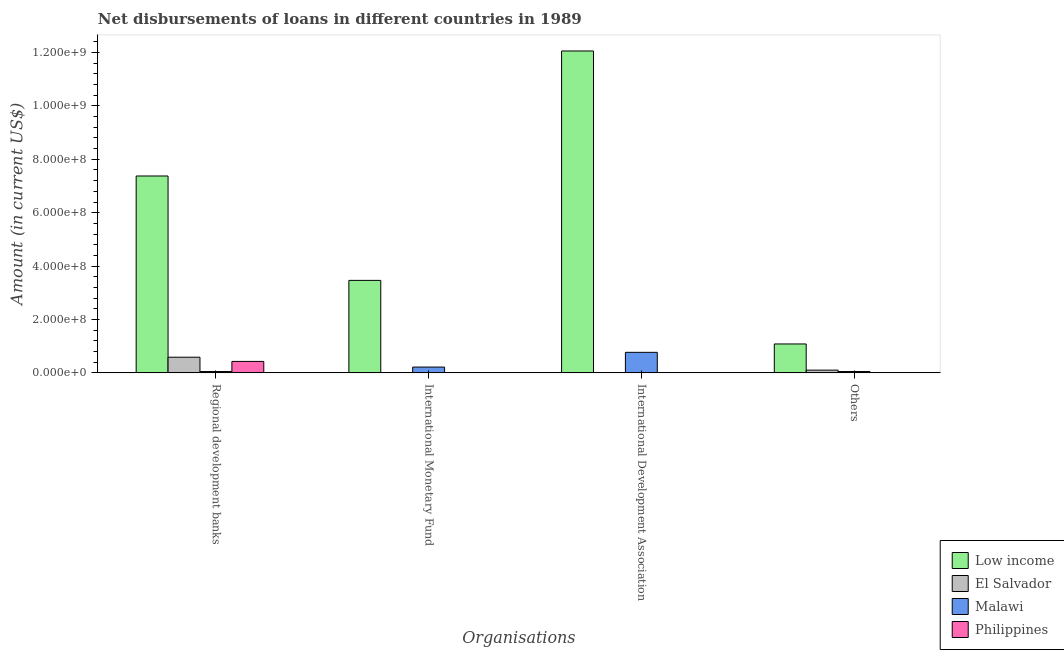How many different coloured bars are there?
Offer a terse response. 4. How many groups of bars are there?
Your response must be concise. 4. Are the number of bars on each tick of the X-axis equal?
Your response must be concise. No. What is the label of the 3rd group of bars from the left?
Offer a very short reply. International Development Association. What is the amount of loan disimbursed by international development association in Philippines?
Offer a very short reply. 6.10e+05. Across all countries, what is the maximum amount of loan disimbursed by other organisations?
Offer a terse response. 1.08e+08. What is the total amount of loan disimbursed by other organisations in the graph?
Make the answer very short. 1.24e+08. What is the difference between the amount of loan disimbursed by regional development banks in Malawi and that in Low income?
Give a very brief answer. -7.33e+08. What is the difference between the amount of loan disimbursed by international development association in Philippines and the amount of loan disimbursed by regional development banks in El Salvador?
Offer a terse response. -5.80e+07. What is the average amount of loan disimbursed by other organisations per country?
Offer a terse response. 3.09e+07. What is the difference between the amount of loan disimbursed by international monetary fund and amount of loan disimbursed by international development association in Malawi?
Ensure brevity in your answer.  -5.52e+07. In how many countries, is the amount of loan disimbursed by regional development banks greater than 680000000 US$?
Offer a very short reply. 1. What is the ratio of the amount of loan disimbursed by international development association in Malawi to that in Philippines?
Offer a terse response. 126.05. Is the difference between the amount of loan disimbursed by other organisations in Low income and Malawi greater than the difference between the amount of loan disimbursed by international development association in Low income and Malawi?
Give a very brief answer. No. What is the difference between the highest and the second highest amount of loan disimbursed by international development association?
Make the answer very short. 1.13e+09. What is the difference between the highest and the lowest amount of loan disimbursed by international monetary fund?
Provide a short and direct response. 3.46e+08. In how many countries, is the amount of loan disimbursed by international monetary fund greater than the average amount of loan disimbursed by international monetary fund taken over all countries?
Give a very brief answer. 1. Is the sum of the amount of loan disimbursed by other organisations in Malawi and El Salvador greater than the maximum amount of loan disimbursed by international development association across all countries?
Keep it short and to the point. No. Are all the bars in the graph horizontal?
Your answer should be compact. No. Does the graph contain any zero values?
Keep it short and to the point. Yes. Does the graph contain grids?
Provide a short and direct response. No. How are the legend labels stacked?
Your response must be concise. Vertical. What is the title of the graph?
Your response must be concise. Net disbursements of loans in different countries in 1989. What is the label or title of the X-axis?
Ensure brevity in your answer.  Organisations. What is the Amount (in current US$) of Low income in Regional development banks?
Ensure brevity in your answer.  7.38e+08. What is the Amount (in current US$) of El Salvador in Regional development banks?
Make the answer very short. 5.87e+07. What is the Amount (in current US$) in Malawi in Regional development banks?
Provide a succinct answer. 4.95e+06. What is the Amount (in current US$) of Philippines in Regional development banks?
Offer a very short reply. 4.29e+07. What is the Amount (in current US$) in Low income in International Monetary Fund?
Keep it short and to the point. 3.46e+08. What is the Amount (in current US$) of Malawi in International Monetary Fund?
Your response must be concise. 2.17e+07. What is the Amount (in current US$) of Philippines in International Monetary Fund?
Ensure brevity in your answer.  0. What is the Amount (in current US$) in Low income in International Development Association?
Ensure brevity in your answer.  1.21e+09. What is the Amount (in current US$) of El Salvador in International Development Association?
Provide a short and direct response. 0. What is the Amount (in current US$) in Malawi in International Development Association?
Keep it short and to the point. 7.69e+07. What is the Amount (in current US$) of Philippines in International Development Association?
Keep it short and to the point. 6.10e+05. What is the Amount (in current US$) of Low income in Others?
Offer a very short reply. 1.08e+08. What is the Amount (in current US$) in El Salvador in Others?
Provide a succinct answer. 1.02e+07. What is the Amount (in current US$) of Malawi in Others?
Offer a very short reply. 4.99e+06. Across all Organisations, what is the maximum Amount (in current US$) of Low income?
Your answer should be compact. 1.21e+09. Across all Organisations, what is the maximum Amount (in current US$) in El Salvador?
Offer a terse response. 5.87e+07. Across all Organisations, what is the maximum Amount (in current US$) of Malawi?
Provide a short and direct response. 7.69e+07. Across all Organisations, what is the maximum Amount (in current US$) in Philippines?
Provide a short and direct response. 4.29e+07. Across all Organisations, what is the minimum Amount (in current US$) of Low income?
Offer a very short reply. 1.08e+08. Across all Organisations, what is the minimum Amount (in current US$) of Malawi?
Keep it short and to the point. 4.95e+06. Across all Organisations, what is the minimum Amount (in current US$) of Philippines?
Your response must be concise. 0. What is the total Amount (in current US$) in Low income in the graph?
Offer a terse response. 2.40e+09. What is the total Amount (in current US$) in El Salvador in the graph?
Keep it short and to the point. 6.89e+07. What is the total Amount (in current US$) in Malawi in the graph?
Your response must be concise. 1.09e+08. What is the total Amount (in current US$) in Philippines in the graph?
Provide a short and direct response. 4.35e+07. What is the difference between the Amount (in current US$) of Low income in Regional development banks and that in International Monetary Fund?
Your answer should be very brief. 3.91e+08. What is the difference between the Amount (in current US$) in Malawi in Regional development banks and that in International Monetary Fund?
Your answer should be compact. -1.67e+07. What is the difference between the Amount (in current US$) of Low income in Regional development banks and that in International Development Association?
Your answer should be compact. -4.68e+08. What is the difference between the Amount (in current US$) in Malawi in Regional development banks and that in International Development Association?
Your answer should be very brief. -7.19e+07. What is the difference between the Amount (in current US$) in Philippines in Regional development banks and that in International Development Association?
Make the answer very short. 4.23e+07. What is the difference between the Amount (in current US$) in Low income in Regional development banks and that in Others?
Provide a succinct answer. 6.29e+08. What is the difference between the Amount (in current US$) of El Salvador in Regional development banks and that in Others?
Ensure brevity in your answer.  4.84e+07. What is the difference between the Amount (in current US$) of Malawi in Regional development banks and that in Others?
Give a very brief answer. -4.00e+04. What is the difference between the Amount (in current US$) of Low income in International Monetary Fund and that in International Development Association?
Ensure brevity in your answer.  -8.59e+08. What is the difference between the Amount (in current US$) of Malawi in International Monetary Fund and that in International Development Association?
Your answer should be very brief. -5.52e+07. What is the difference between the Amount (in current US$) in Low income in International Monetary Fund and that in Others?
Your response must be concise. 2.38e+08. What is the difference between the Amount (in current US$) of Malawi in International Monetary Fund and that in Others?
Your answer should be very brief. 1.67e+07. What is the difference between the Amount (in current US$) in Low income in International Development Association and that in Others?
Your answer should be very brief. 1.10e+09. What is the difference between the Amount (in current US$) of Malawi in International Development Association and that in Others?
Provide a short and direct response. 7.19e+07. What is the difference between the Amount (in current US$) of Low income in Regional development banks and the Amount (in current US$) of Malawi in International Monetary Fund?
Ensure brevity in your answer.  7.16e+08. What is the difference between the Amount (in current US$) in El Salvador in Regional development banks and the Amount (in current US$) in Malawi in International Monetary Fund?
Your response must be concise. 3.70e+07. What is the difference between the Amount (in current US$) of Low income in Regional development banks and the Amount (in current US$) of Malawi in International Development Association?
Your answer should be compact. 6.61e+08. What is the difference between the Amount (in current US$) in Low income in Regional development banks and the Amount (in current US$) in Philippines in International Development Association?
Offer a very short reply. 7.37e+08. What is the difference between the Amount (in current US$) in El Salvador in Regional development banks and the Amount (in current US$) in Malawi in International Development Association?
Keep it short and to the point. -1.82e+07. What is the difference between the Amount (in current US$) of El Salvador in Regional development banks and the Amount (in current US$) of Philippines in International Development Association?
Make the answer very short. 5.80e+07. What is the difference between the Amount (in current US$) of Malawi in Regional development banks and the Amount (in current US$) of Philippines in International Development Association?
Give a very brief answer. 4.34e+06. What is the difference between the Amount (in current US$) in Low income in Regional development banks and the Amount (in current US$) in El Salvador in Others?
Your answer should be compact. 7.27e+08. What is the difference between the Amount (in current US$) in Low income in Regional development banks and the Amount (in current US$) in Malawi in Others?
Give a very brief answer. 7.33e+08. What is the difference between the Amount (in current US$) of El Salvador in Regional development banks and the Amount (in current US$) of Malawi in Others?
Your answer should be compact. 5.37e+07. What is the difference between the Amount (in current US$) in Low income in International Monetary Fund and the Amount (in current US$) in Malawi in International Development Association?
Your answer should be compact. 2.70e+08. What is the difference between the Amount (in current US$) of Low income in International Monetary Fund and the Amount (in current US$) of Philippines in International Development Association?
Your response must be concise. 3.46e+08. What is the difference between the Amount (in current US$) of Malawi in International Monetary Fund and the Amount (in current US$) of Philippines in International Development Association?
Your answer should be very brief. 2.11e+07. What is the difference between the Amount (in current US$) of Low income in International Monetary Fund and the Amount (in current US$) of El Salvador in Others?
Your response must be concise. 3.36e+08. What is the difference between the Amount (in current US$) of Low income in International Monetary Fund and the Amount (in current US$) of Malawi in Others?
Your answer should be compact. 3.41e+08. What is the difference between the Amount (in current US$) in Low income in International Development Association and the Amount (in current US$) in El Salvador in Others?
Ensure brevity in your answer.  1.20e+09. What is the difference between the Amount (in current US$) in Low income in International Development Association and the Amount (in current US$) in Malawi in Others?
Offer a terse response. 1.20e+09. What is the average Amount (in current US$) of Low income per Organisations?
Provide a succinct answer. 6.00e+08. What is the average Amount (in current US$) of El Salvador per Organisations?
Provide a succinct answer. 1.72e+07. What is the average Amount (in current US$) in Malawi per Organisations?
Offer a very short reply. 2.71e+07. What is the average Amount (in current US$) of Philippines per Organisations?
Keep it short and to the point. 1.09e+07. What is the difference between the Amount (in current US$) of Low income and Amount (in current US$) of El Salvador in Regional development banks?
Your answer should be compact. 6.79e+08. What is the difference between the Amount (in current US$) of Low income and Amount (in current US$) of Malawi in Regional development banks?
Keep it short and to the point. 7.33e+08. What is the difference between the Amount (in current US$) of Low income and Amount (in current US$) of Philippines in Regional development banks?
Provide a short and direct response. 6.95e+08. What is the difference between the Amount (in current US$) in El Salvador and Amount (in current US$) in Malawi in Regional development banks?
Give a very brief answer. 5.37e+07. What is the difference between the Amount (in current US$) in El Salvador and Amount (in current US$) in Philippines in Regional development banks?
Give a very brief answer. 1.58e+07. What is the difference between the Amount (in current US$) in Malawi and Amount (in current US$) in Philippines in Regional development banks?
Offer a very short reply. -3.79e+07. What is the difference between the Amount (in current US$) of Low income and Amount (in current US$) of Malawi in International Monetary Fund?
Keep it short and to the point. 3.25e+08. What is the difference between the Amount (in current US$) in Low income and Amount (in current US$) in Malawi in International Development Association?
Make the answer very short. 1.13e+09. What is the difference between the Amount (in current US$) in Low income and Amount (in current US$) in Philippines in International Development Association?
Give a very brief answer. 1.21e+09. What is the difference between the Amount (in current US$) in Malawi and Amount (in current US$) in Philippines in International Development Association?
Give a very brief answer. 7.63e+07. What is the difference between the Amount (in current US$) of Low income and Amount (in current US$) of El Salvador in Others?
Ensure brevity in your answer.  9.81e+07. What is the difference between the Amount (in current US$) of Low income and Amount (in current US$) of Malawi in Others?
Keep it short and to the point. 1.03e+08. What is the difference between the Amount (in current US$) of El Salvador and Amount (in current US$) of Malawi in Others?
Give a very brief answer. 5.24e+06. What is the ratio of the Amount (in current US$) in Low income in Regional development banks to that in International Monetary Fund?
Give a very brief answer. 2.13. What is the ratio of the Amount (in current US$) in Malawi in Regional development banks to that in International Monetary Fund?
Provide a short and direct response. 0.23. What is the ratio of the Amount (in current US$) in Low income in Regional development banks to that in International Development Association?
Your response must be concise. 0.61. What is the ratio of the Amount (in current US$) in Malawi in Regional development banks to that in International Development Association?
Provide a succinct answer. 0.06. What is the ratio of the Amount (in current US$) in Philippines in Regional development banks to that in International Development Association?
Make the answer very short. 70.32. What is the ratio of the Amount (in current US$) in Low income in Regional development banks to that in Others?
Your answer should be very brief. 6.81. What is the ratio of the Amount (in current US$) of El Salvador in Regional development banks to that in Others?
Make the answer very short. 5.73. What is the ratio of the Amount (in current US$) of Malawi in Regional development banks to that in Others?
Keep it short and to the point. 0.99. What is the ratio of the Amount (in current US$) in Low income in International Monetary Fund to that in International Development Association?
Your answer should be very brief. 0.29. What is the ratio of the Amount (in current US$) in Malawi in International Monetary Fund to that in International Development Association?
Make the answer very short. 0.28. What is the ratio of the Amount (in current US$) of Low income in International Monetary Fund to that in Others?
Make the answer very short. 3.2. What is the ratio of the Amount (in current US$) in Malawi in International Monetary Fund to that in Others?
Give a very brief answer. 4.35. What is the ratio of the Amount (in current US$) in Low income in International Development Association to that in Others?
Your answer should be compact. 11.13. What is the ratio of the Amount (in current US$) of Malawi in International Development Association to that in Others?
Make the answer very short. 15.41. What is the difference between the highest and the second highest Amount (in current US$) of Low income?
Ensure brevity in your answer.  4.68e+08. What is the difference between the highest and the second highest Amount (in current US$) of Malawi?
Your response must be concise. 5.52e+07. What is the difference between the highest and the lowest Amount (in current US$) in Low income?
Offer a terse response. 1.10e+09. What is the difference between the highest and the lowest Amount (in current US$) in El Salvador?
Make the answer very short. 5.87e+07. What is the difference between the highest and the lowest Amount (in current US$) of Malawi?
Ensure brevity in your answer.  7.19e+07. What is the difference between the highest and the lowest Amount (in current US$) of Philippines?
Provide a succinct answer. 4.29e+07. 